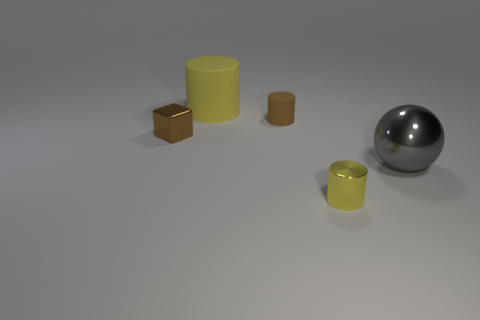Subtract 1 cylinders. How many cylinders are left? 2 Add 3 big green metallic cylinders. How many objects exist? 8 Subtract all cubes. How many objects are left? 4 Subtract 0 green cylinders. How many objects are left? 5 Subtract all tiny gray objects. Subtract all yellow rubber cylinders. How many objects are left? 4 Add 1 yellow cylinders. How many yellow cylinders are left? 3 Add 5 yellow metallic cylinders. How many yellow metallic cylinders exist? 6 